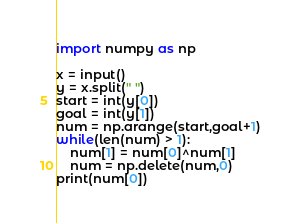<code> <loc_0><loc_0><loc_500><loc_500><_Python_>import numpy as np

x = input()
y = x.split(" ")
start = int(y[0])
goal = int(y[1])
num = np.arange(start,goal+1)
while(len(num) > 1):
    num[1] = num[0]^num[1]
    num = np.delete(num,0)
print(num[0])</code> 